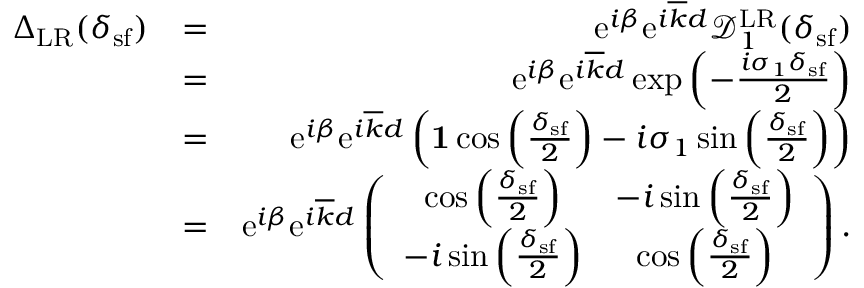Convert formula to latex. <formula><loc_0><loc_0><loc_500><loc_500>\begin{array} { r l r } { { \Delta } _ { L R } ( \delta _ { s f } ) } & { = } & { e ^ { i \beta } e ^ { i \overline { k } d } \mathcal { D } _ { 1 } ^ { L R } ( \delta _ { s f } ) } \\ & { = } & { e ^ { i \beta } e ^ { i \overline { k } d } \exp \left ( - \frac { i \sigma _ { 1 } \delta _ { s f } } { 2 } \right ) } \\ & { = } & { e ^ { i \beta } e ^ { i \overline { k } d } \left ( { 1 } \cos \left ( \frac { \delta _ { s f } } { 2 } \right ) - i \sigma _ { 1 } \sin \left ( \frac { \delta _ { s f } } { 2 } \right ) \right ) } \\ & { = } & { e ^ { i \beta } e ^ { i \overline { k } d } \left ( \begin{array} { c c } { \cos \left ( \frac { \delta _ { s f } } { 2 } \right ) } & { - i \sin \left ( \frac { \delta _ { s f } } { 2 } \right ) } \\ { - i \sin \left ( \frac { \delta _ { s f } } { 2 } \right ) } & { \cos \left ( \frac { \delta _ { s f } } { 2 } \right ) } \end{array} \right ) . } \end{array}</formula> 